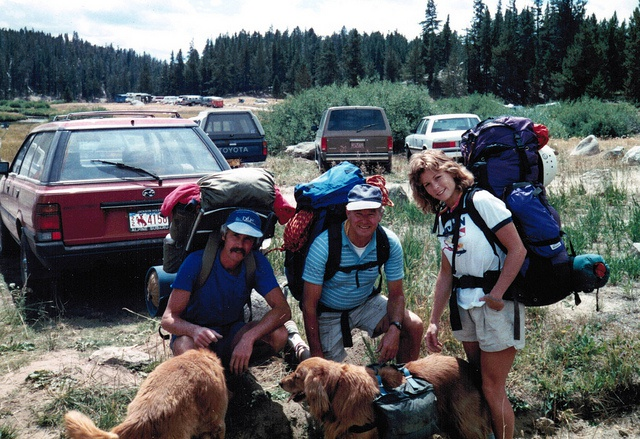Describe the objects in this image and their specific colors. I can see car in white, black, maroon, lightgray, and lightblue tones, people in white, black, gray, maroon, and darkgray tones, people in white, black, maroon, blue, and gray tones, dog in white, black, maroon, gray, and brown tones, and people in white, black, maroon, navy, and brown tones in this image. 